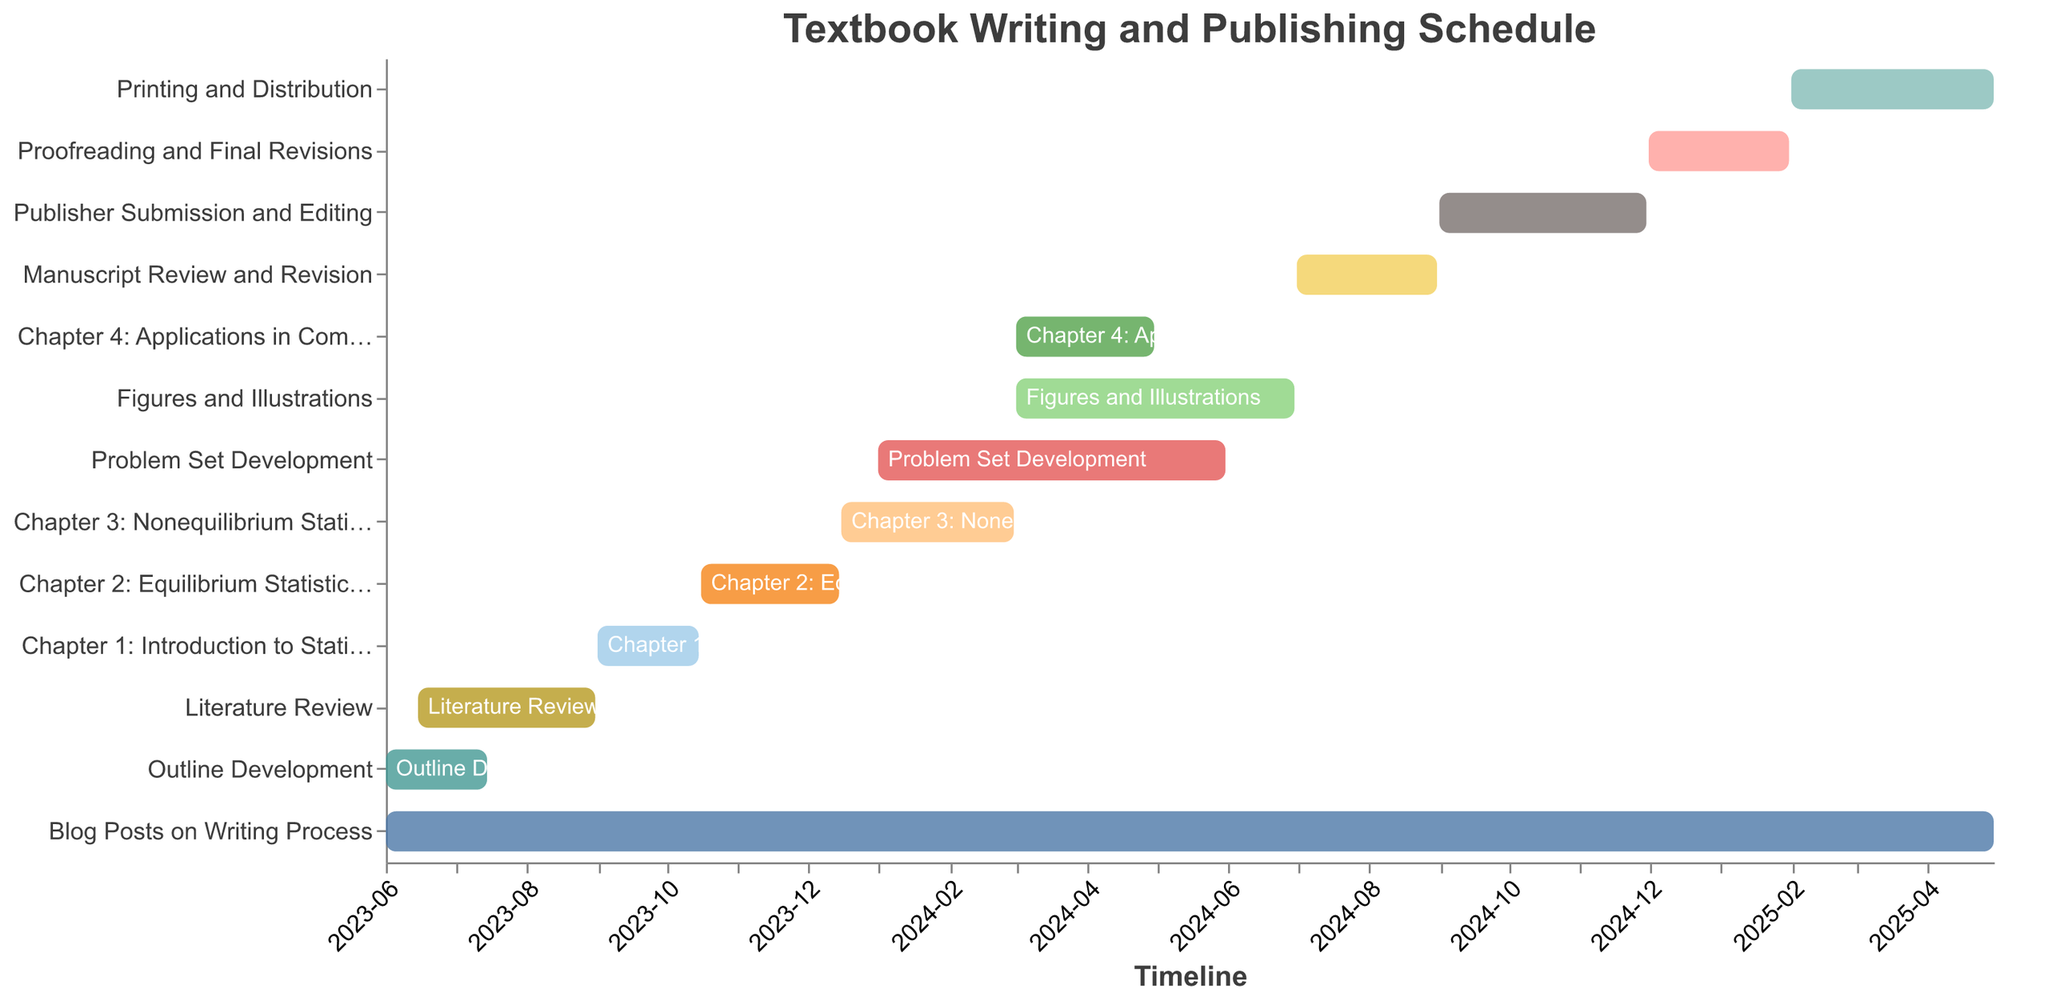What's the title of the figure? The title of the figure appears at the top of the Gantt chart and is a descriptive phrase summarizing the chart's content.
Answer: Textbook Writing and Publishing Schedule Which tasks are expected to start in June 2023? Identification of tasks that have a "Start Date" in June 2023. By scanning the Gantt chart, both "Outline Development" and "Literature Review" are observed to start in June 2023.
Answer: Outline Development, Literature Review What is the duration of the "Manuscript Review and Revision" phase? The duration can be calculated by noting the start and end dates of the phase. From July 1, 2024, to August 31, 2024, it spans two months.
Answer: 2 months Which task overlaps with "Figures and Illustrations"? To find overlapping tasks, compare the start and end dates of "Figures and Illustrations" with other tasks. Overlaps are with "Problem Set Development" (Jan 2024 – May 31, 2024) and "Chapter 4: Applications in Complex Systems" (Mar 1, 2024 – Apr 30, 2024).
Answer: Problem Set Development, Chapter 4: Applications in Complex Systems Which task has the longest duration? By comparing the start and end dates of all tasks, "Blog Posts on Writing Process" (June 1, 2023 – April 30, 2025) spans the longest duration.
Answer: Blog Posts on Writing Process When is the "Publishing and Distribution" phase scheduled to end? The end date for "Publishing and Distribution" is provided directly on the Gantt chart. By locating this task and identifying the "End Date," it is April 30, 2025.
Answer: April 30, 2025 What is the earliest start date among all tasks? By identifying the "Start Date" for all tasks, "Outline Development" and "Blog Posts on Writing Process" both start on June 1, 2023, which is the earliest date on the chart.
Answer: June 1, 2023 How long does the "Chapter Writing" phase (sum of Chapter 1 to Chapter 4) take? To calculate the duration of the "Chapter Writing" phase, sum the durations of Chapter 1 (Sep 1, 2023 – Oct 15, 2023), Chapter 2 (Oct 16, 2023 – Dec 15, 2023), Chapter 3 (Dec 16, 2023 – Feb 29, 2024), and Chapter 4 (Mar 1, 2024 – Apr 30, 2024). The combined duration is approximately 8.5 months.
Answer: 8.5 months 